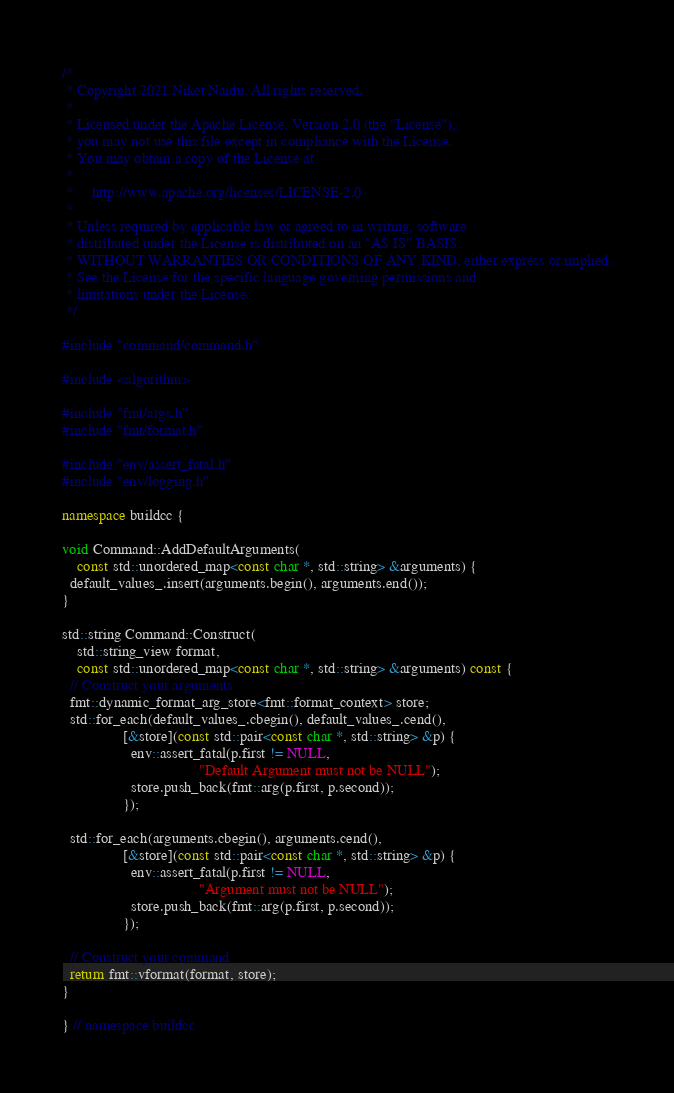<code> <loc_0><loc_0><loc_500><loc_500><_C++_>/*
 * Copyright 2021 Niket Naidu. All rights reserved.
 *
 * Licensed under the Apache License, Version 2.0 (the "License");
 * you may not use this file except in compliance with the License.
 * You may obtain a copy of the License at
 *
 *     http://www.apache.org/licenses/LICENSE-2.0
 *
 * Unless required by applicable law or agreed to in writing, software
 * distributed under the License is distributed on an "AS IS" BASIS,
 * WITHOUT WARRANTIES OR CONDITIONS OF ANY KIND, either express or implied.
 * See the License for the specific language governing permissions and
 * limitations under the License.
 */

#include "command/command.h"

#include <algorithm>

#include "fmt/args.h"
#include "fmt/format.h"

#include "env/assert_fatal.h"
#include "env/logging.h"

namespace buildcc {

void Command::AddDefaultArguments(
    const std::unordered_map<const char *, std::string> &arguments) {
  default_values_.insert(arguments.begin(), arguments.end());
}

std::string Command::Construct(
    std::string_view format,
    const std::unordered_map<const char *, std::string> &arguments) const {
  // Construct your arguments
  fmt::dynamic_format_arg_store<fmt::format_context> store;
  std::for_each(default_values_.cbegin(), default_values_.cend(),
                [&store](const std::pair<const char *, std::string> &p) {
                  env::assert_fatal(p.first != NULL,
                                    "Default Argument must not be NULL");
                  store.push_back(fmt::arg(p.first, p.second));
                });

  std::for_each(arguments.cbegin(), arguments.cend(),
                [&store](const std::pair<const char *, std::string> &p) {
                  env::assert_fatal(p.first != NULL,
                                    "Argument must not be NULL");
                  store.push_back(fmt::arg(p.first, p.second));
                });

  // Construct your command
  return fmt::vformat(format, store);
}

} // namespace buildcc
</code> 